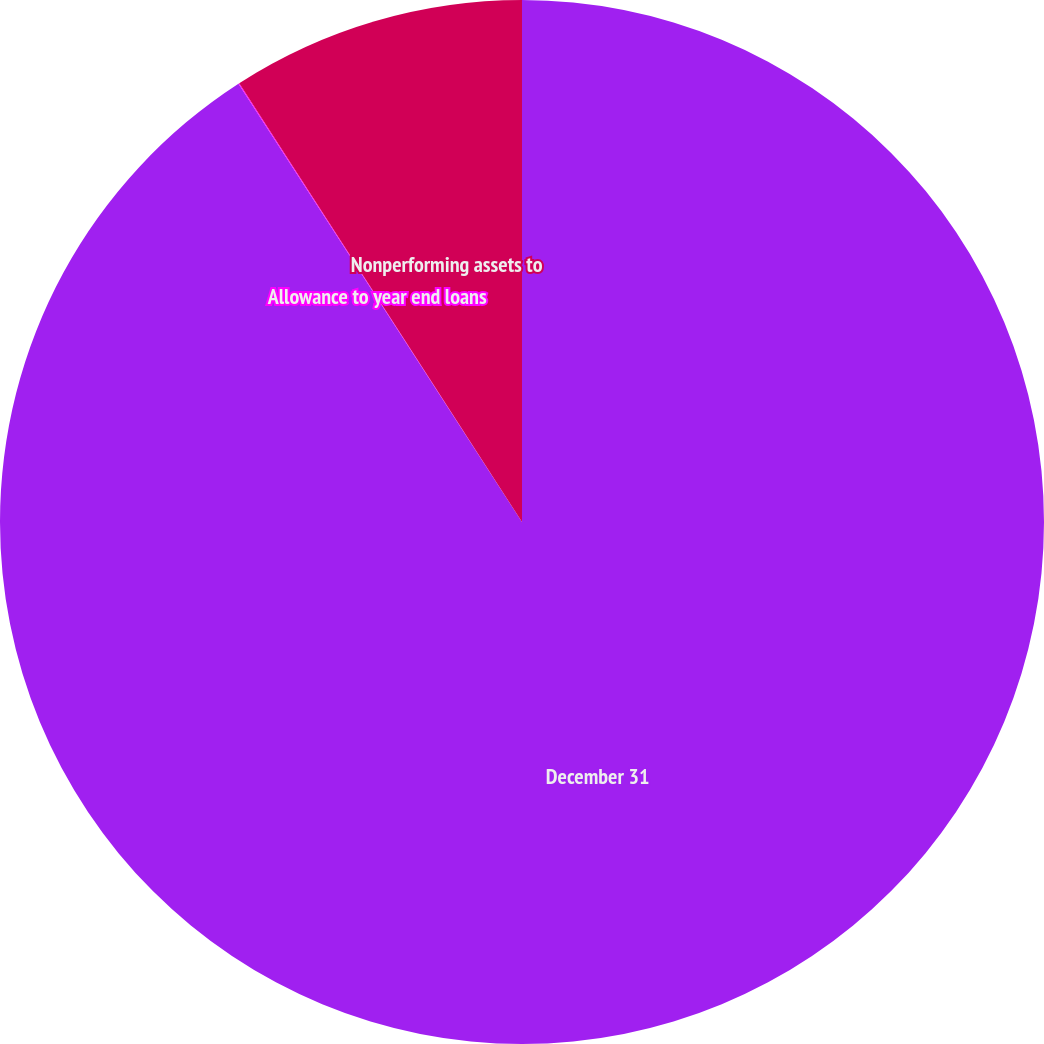Convert chart to OTSL. <chart><loc_0><loc_0><loc_500><loc_500><pie_chart><fcel>December 31<fcel>Allowance to year end loans<fcel>Nonperforming assets to<nl><fcel>90.86%<fcel>0.03%<fcel>9.11%<nl></chart> 